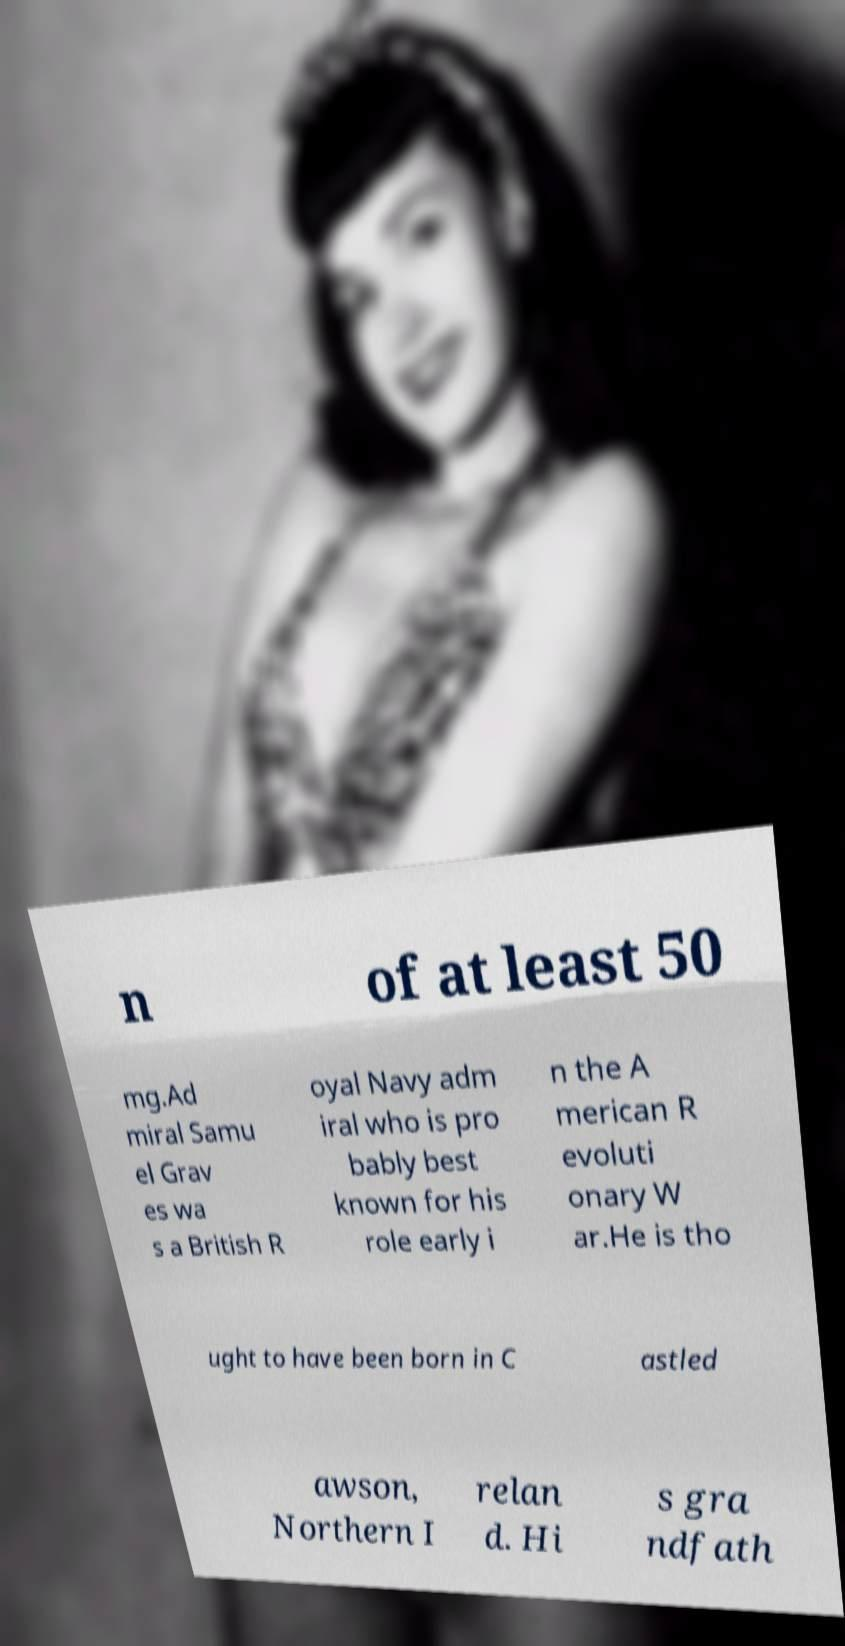I need the written content from this picture converted into text. Can you do that? n of at least 50 mg.Ad miral Samu el Grav es wa s a British R oyal Navy adm iral who is pro bably best known for his role early i n the A merican R evoluti onary W ar.He is tho ught to have been born in C astled awson, Northern I relan d. Hi s gra ndfath 